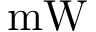<formula> <loc_0><loc_0><loc_500><loc_500>m W</formula> 